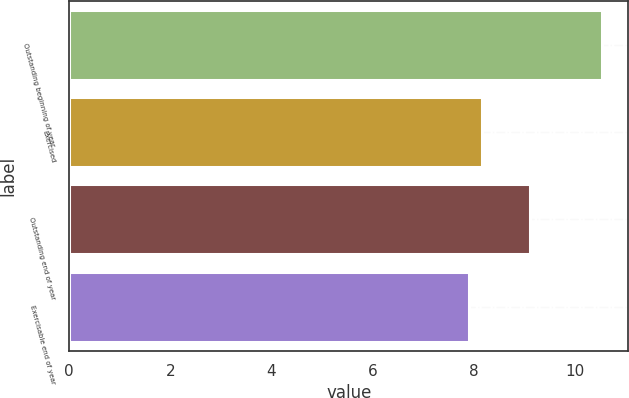<chart> <loc_0><loc_0><loc_500><loc_500><bar_chart><fcel>Outstanding beginning of year<fcel>Exercised<fcel>Outstanding end of year<fcel>Exercisable end of year<nl><fcel>10.53<fcel>8.16<fcel>9.12<fcel>7.9<nl></chart> 